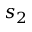Convert formula to latex. <formula><loc_0><loc_0><loc_500><loc_500>s _ { 2 }</formula> 